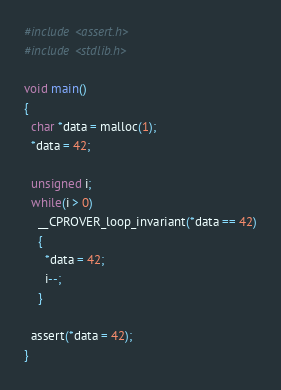Convert code to text. <code><loc_0><loc_0><loc_500><loc_500><_C_>#include <assert.h>
#include <stdlib.h>

void main()
{
  char *data = malloc(1);
  *data = 42;

  unsigned i;
  while(i > 0)
    __CPROVER_loop_invariant(*data == 42)
    {
      *data = 42;
      i--;
    }

  assert(*data = 42);
}
</code> 